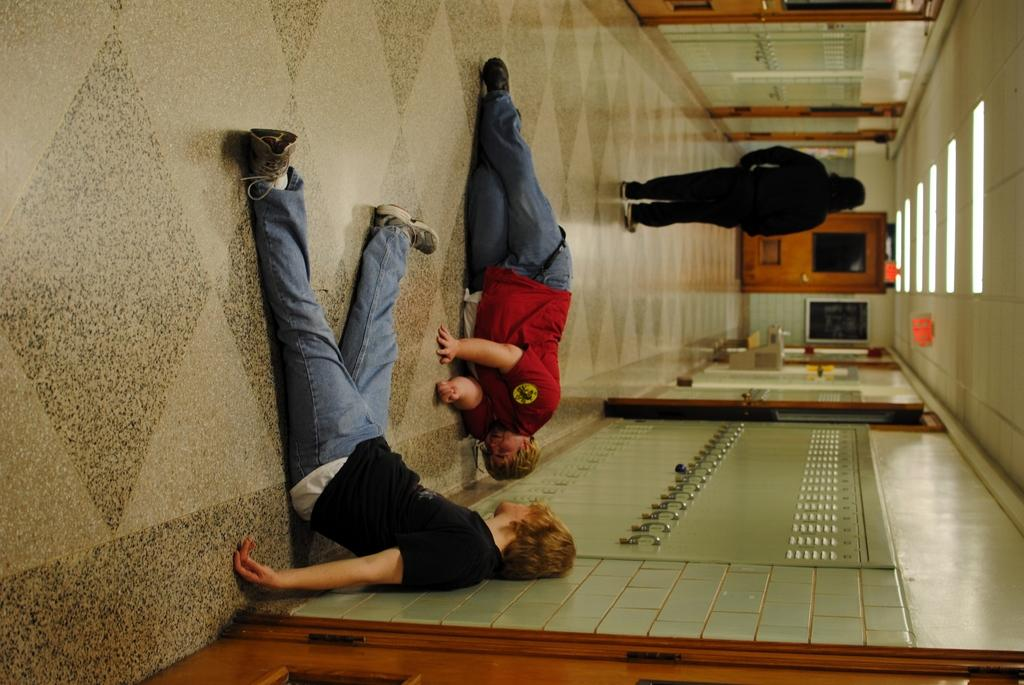What is the position of the first person in the image? There is a person sitting on the floor. What is the position of the second person in the image? There is a person laying on the floor. What is the position of the third person in the image? There is a person standing. What type of storage units can be seen in the image? There are lockers in the image. What type of lighting is present in the image? There are lights in the image. What is attached to the wall in the image? There is a frame attached to the wall. What type of entryways are visible in the image? There are doors in the image. What thrilling invention can be seen in the hands of the person standing in the image? There is no invention or thrilling activity present in the image; the people are simply sitting, laying, or standing. 